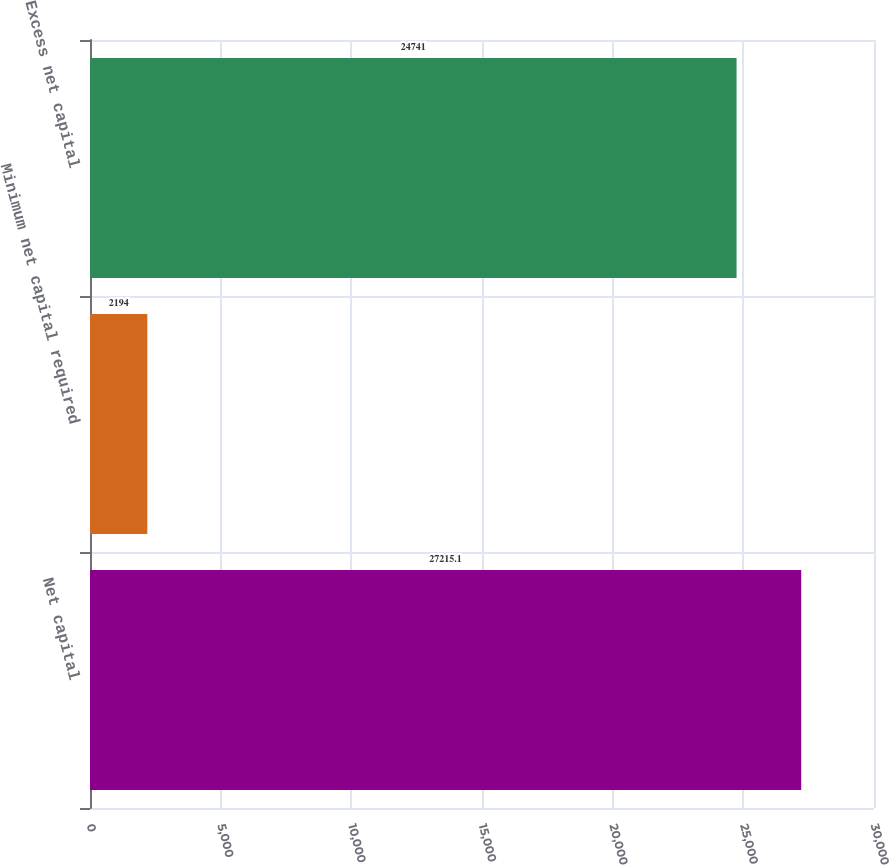Convert chart to OTSL. <chart><loc_0><loc_0><loc_500><loc_500><bar_chart><fcel>Net capital<fcel>Minimum net capital required<fcel>Excess net capital<nl><fcel>27215.1<fcel>2194<fcel>24741<nl></chart> 